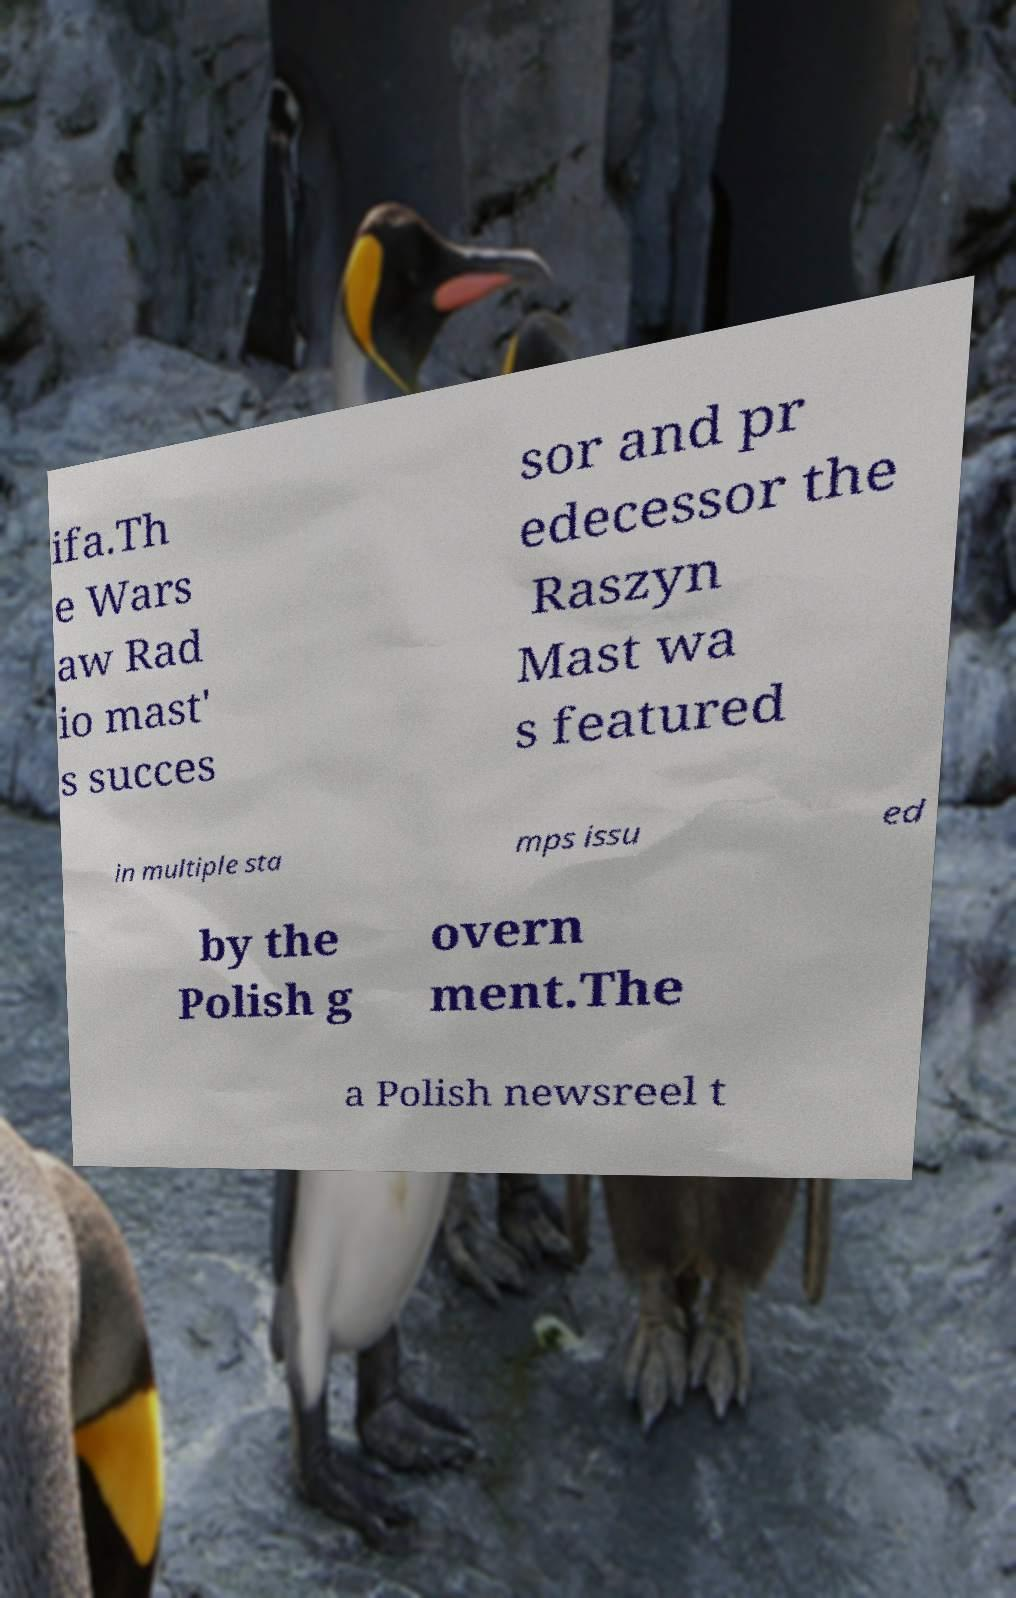What messages or text are displayed in this image? I need them in a readable, typed format. ifa.Th e Wars aw Rad io mast' s succes sor and pr edecessor the Raszyn Mast wa s featured in multiple sta mps issu ed by the Polish g overn ment.The a Polish newsreel t 